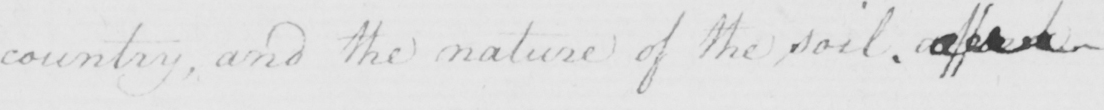What does this handwritten line say? country , and the nature of the soil . affect 